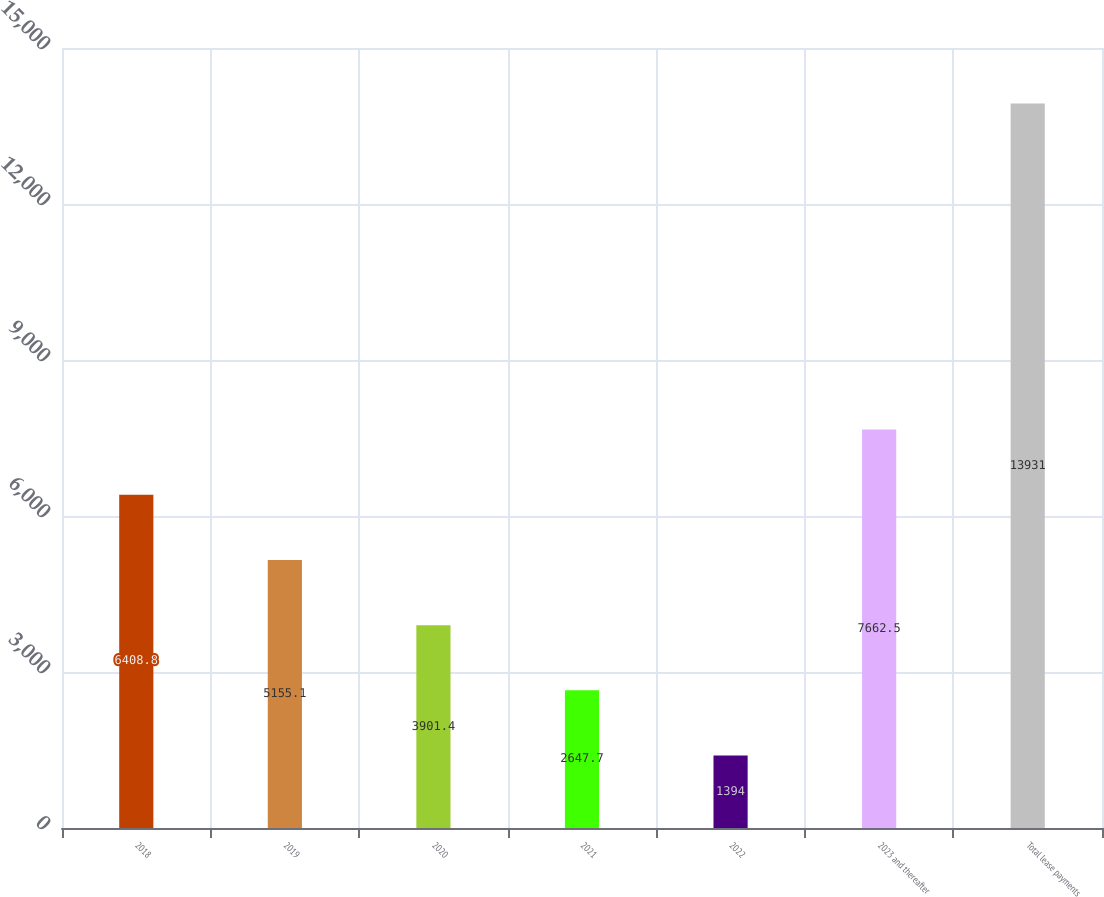Convert chart to OTSL. <chart><loc_0><loc_0><loc_500><loc_500><bar_chart><fcel>2018<fcel>2019<fcel>2020<fcel>2021<fcel>2022<fcel>2023 and thereafter<fcel>Total lease payments<nl><fcel>6408.8<fcel>5155.1<fcel>3901.4<fcel>2647.7<fcel>1394<fcel>7662.5<fcel>13931<nl></chart> 